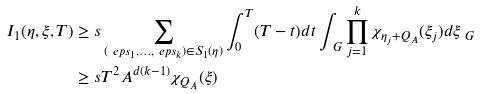Convert formula to latex. <formula><loc_0><loc_0><loc_500><loc_500>I _ { 1 } ( \eta , \xi , T ) & \geq s \sum _ { ( \ e p s _ { 1 } , \dots , \ e p s _ { k } ) \in S _ { 1 } ( \eta ) } \int _ { 0 } ^ { T } ( T - t ) d t \int _ { \ G } \prod _ { j = 1 } ^ { k } \chi _ { \eta _ { j } + Q _ { A } } ( \xi _ { j } ) d \xi _ { \ G } \\ & \geq s T ^ { 2 } A ^ { d ( k - 1 ) } \chi _ { Q _ { A } } ( \xi )</formula> 